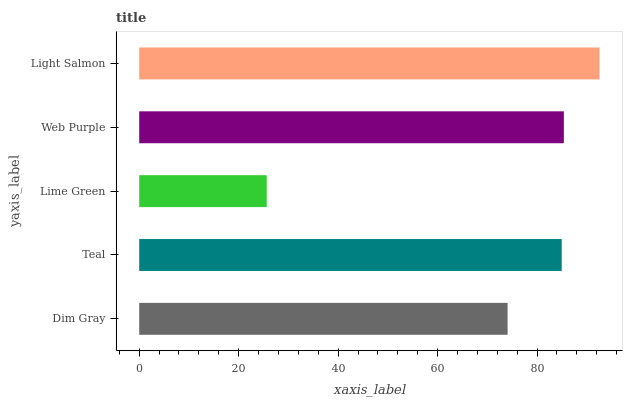Is Lime Green the minimum?
Answer yes or no. Yes. Is Light Salmon the maximum?
Answer yes or no. Yes. Is Teal the minimum?
Answer yes or no. No. Is Teal the maximum?
Answer yes or no. No. Is Teal greater than Dim Gray?
Answer yes or no. Yes. Is Dim Gray less than Teal?
Answer yes or no. Yes. Is Dim Gray greater than Teal?
Answer yes or no. No. Is Teal less than Dim Gray?
Answer yes or no. No. Is Teal the high median?
Answer yes or no. Yes. Is Teal the low median?
Answer yes or no. Yes. Is Web Purple the high median?
Answer yes or no. No. Is Web Purple the low median?
Answer yes or no. No. 